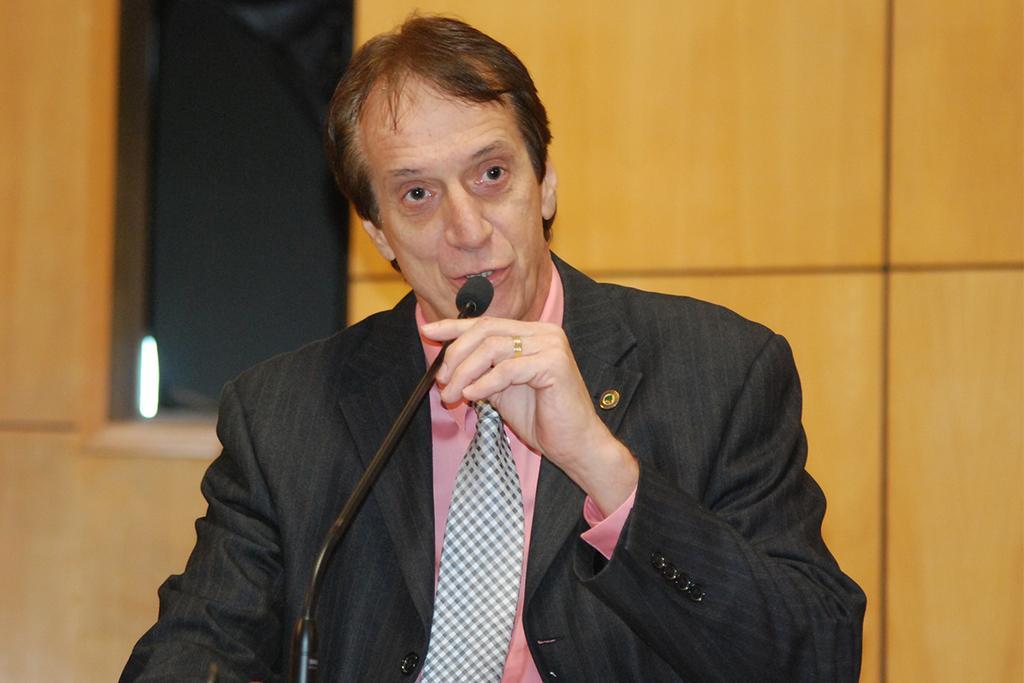Describe this image in one or two sentences. In this picture I can see a man holding a mike, and in the background there is a wall. 